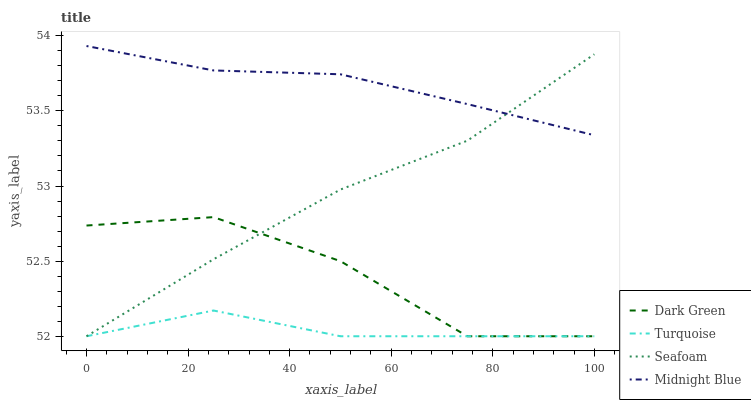Does Turquoise have the minimum area under the curve?
Answer yes or no. Yes. Does Midnight Blue have the maximum area under the curve?
Answer yes or no. Yes. Does Seafoam have the minimum area under the curve?
Answer yes or no. No. Does Seafoam have the maximum area under the curve?
Answer yes or no. No. Is Midnight Blue the smoothest?
Answer yes or no. Yes. Is Dark Green the roughest?
Answer yes or no. Yes. Is Seafoam the smoothest?
Answer yes or no. No. Is Seafoam the roughest?
Answer yes or no. No. Does Midnight Blue have the lowest value?
Answer yes or no. No. Does Midnight Blue have the highest value?
Answer yes or no. Yes. Does Seafoam have the highest value?
Answer yes or no. No. Is Turquoise less than Midnight Blue?
Answer yes or no. Yes. Is Midnight Blue greater than Turquoise?
Answer yes or no. Yes. Does Turquoise intersect Dark Green?
Answer yes or no. Yes. Is Turquoise less than Dark Green?
Answer yes or no. No. Is Turquoise greater than Dark Green?
Answer yes or no. No. Does Turquoise intersect Midnight Blue?
Answer yes or no. No. 